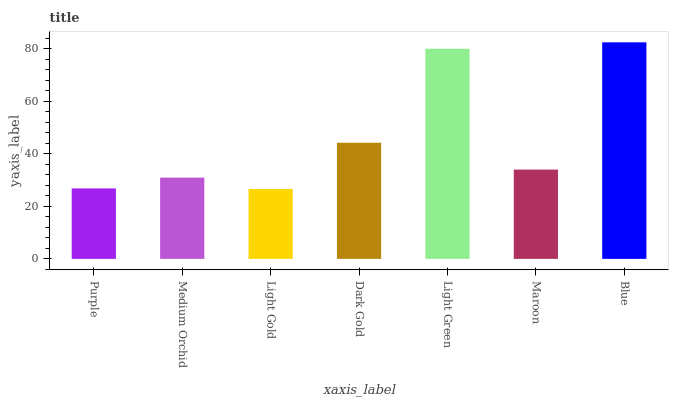Is Light Gold the minimum?
Answer yes or no. Yes. Is Blue the maximum?
Answer yes or no. Yes. Is Medium Orchid the minimum?
Answer yes or no. No. Is Medium Orchid the maximum?
Answer yes or no. No. Is Medium Orchid greater than Purple?
Answer yes or no. Yes. Is Purple less than Medium Orchid?
Answer yes or no. Yes. Is Purple greater than Medium Orchid?
Answer yes or no. No. Is Medium Orchid less than Purple?
Answer yes or no. No. Is Maroon the high median?
Answer yes or no. Yes. Is Maroon the low median?
Answer yes or no. Yes. Is Dark Gold the high median?
Answer yes or no. No. Is Light Gold the low median?
Answer yes or no. No. 